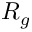Convert formula to latex. <formula><loc_0><loc_0><loc_500><loc_500>R _ { g }</formula> 